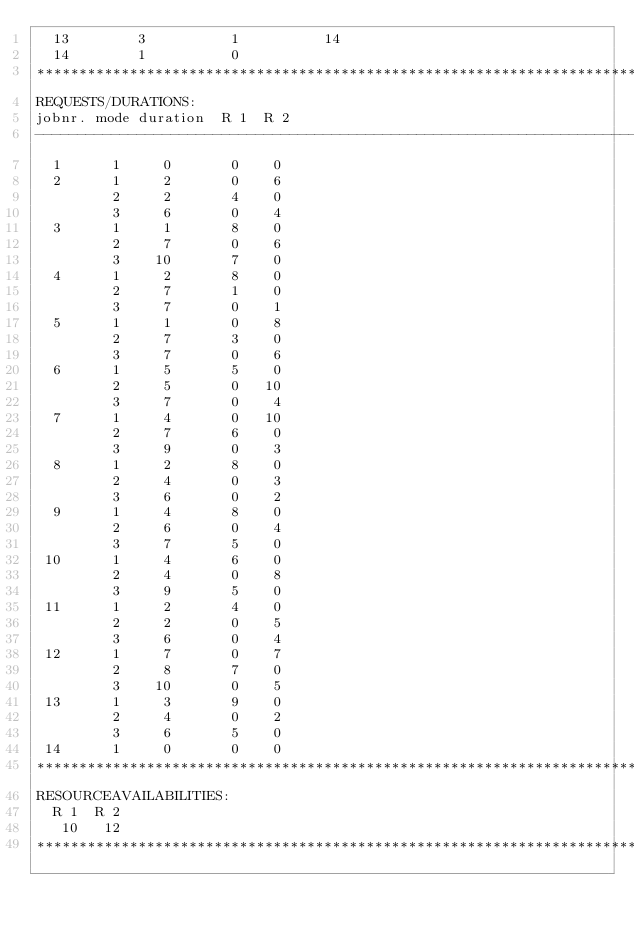<code> <loc_0><loc_0><loc_500><loc_500><_ObjectiveC_>  13        3          1          14
  14        1          0        
************************************************************************
REQUESTS/DURATIONS:
jobnr. mode duration  R 1  R 2
------------------------------------------------------------------------
  1      1     0       0    0
  2      1     2       0    6
         2     2       4    0
         3     6       0    4
  3      1     1       8    0
         2     7       0    6
         3    10       7    0
  4      1     2       8    0
         2     7       1    0
         3     7       0    1
  5      1     1       0    8
         2     7       3    0
         3     7       0    6
  6      1     5       5    0
         2     5       0   10
         3     7       0    4
  7      1     4       0   10
         2     7       6    0
         3     9       0    3
  8      1     2       8    0
         2     4       0    3
         3     6       0    2
  9      1     4       8    0
         2     6       0    4
         3     7       5    0
 10      1     4       6    0
         2     4       0    8
         3     9       5    0
 11      1     2       4    0
         2     2       0    5
         3     6       0    4
 12      1     7       0    7
         2     8       7    0
         3    10       0    5
 13      1     3       9    0
         2     4       0    2
         3     6       5    0
 14      1     0       0    0
************************************************************************
RESOURCEAVAILABILITIES:
  R 1  R 2
   10   12
************************************************************************
</code> 